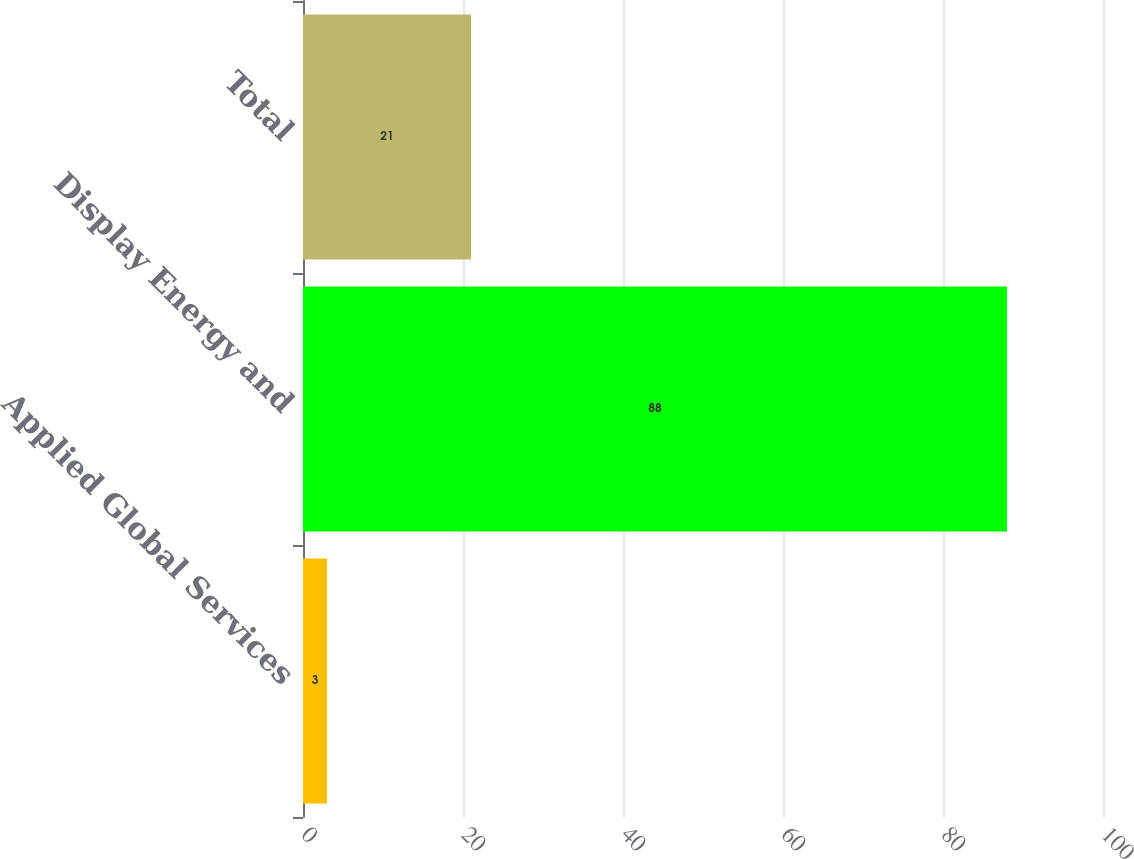Convert chart to OTSL. <chart><loc_0><loc_0><loc_500><loc_500><bar_chart><fcel>Applied Global Services<fcel>Display Energy and<fcel>Total<nl><fcel>3<fcel>88<fcel>21<nl></chart> 